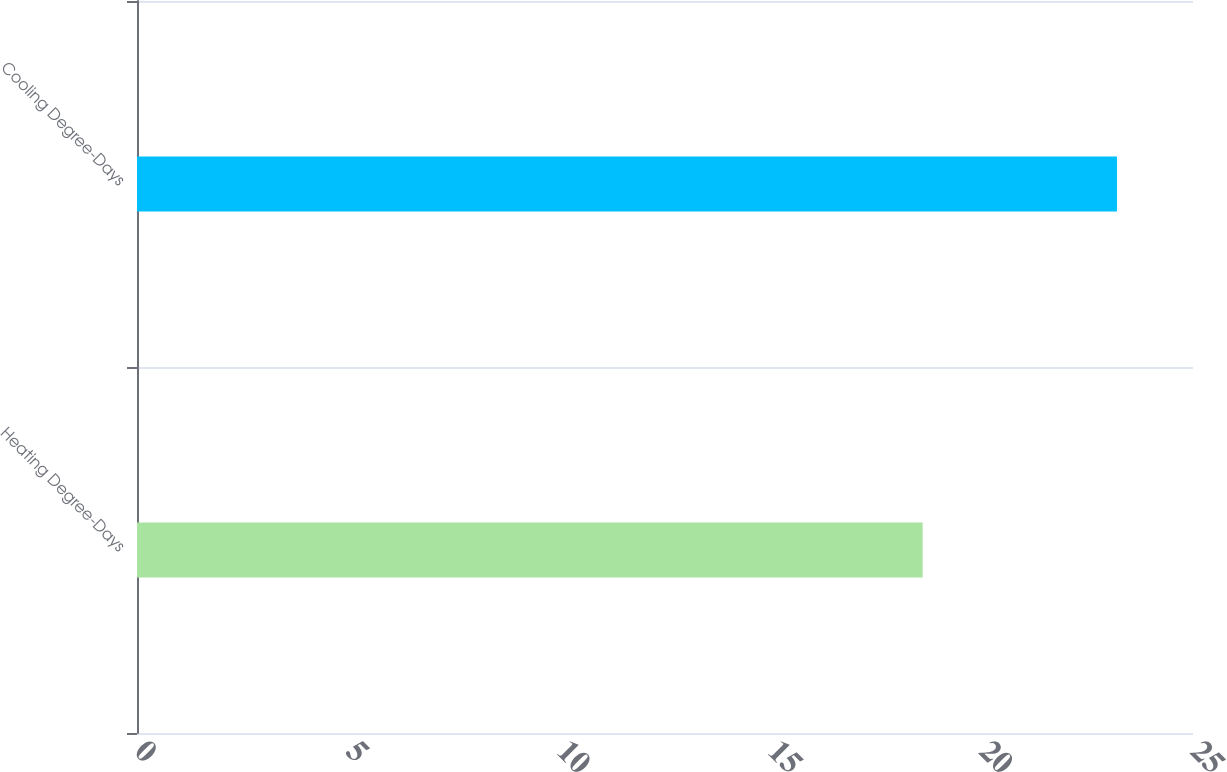Convert chart. <chart><loc_0><loc_0><loc_500><loc_500><bar_chart><fcel>Heating Degree-Days<fcel>Cooling Degree-Days<nl><fcel>18.6<fcel>23.2<nl></chart> 